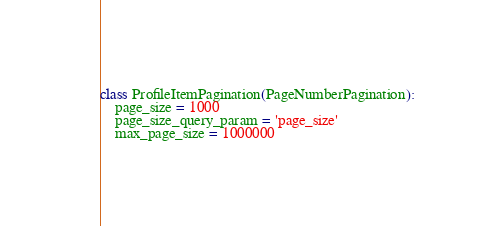<code> <loc_0><loc_0><loc_500><loc_500><_Python_>
class ProfileItemPagination(PageNumberPagination):
    page_size = 1000
    page_size_query_param = 'page_size'
    max_page_size = 1000000
</code> 